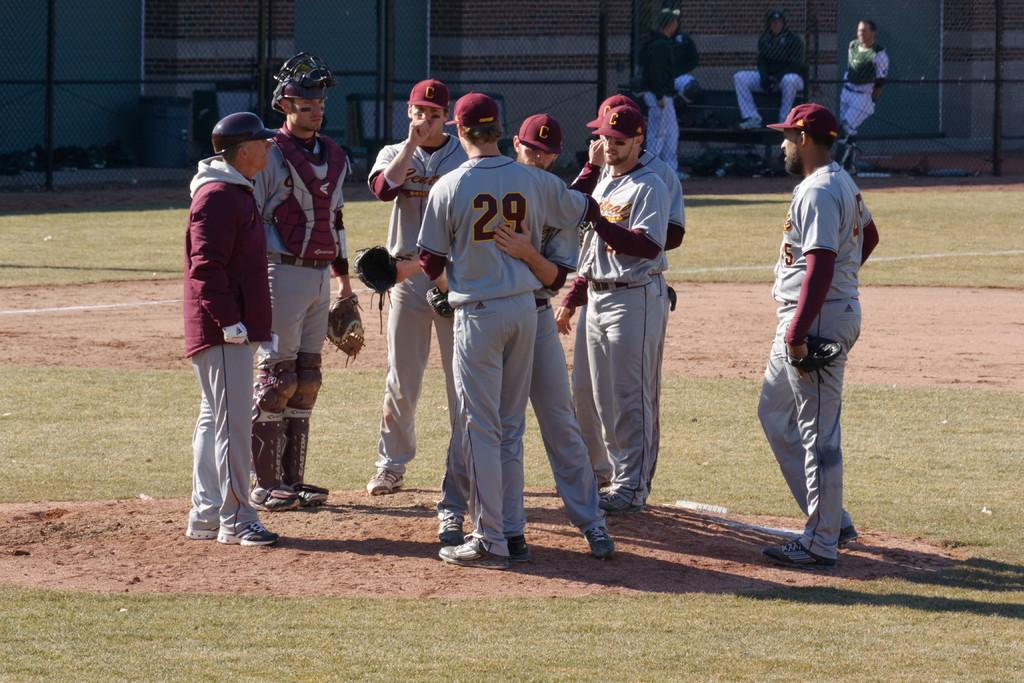<image>
Give a short and clear explanation of the subsequent image. the number 29 that is on the back of the player 